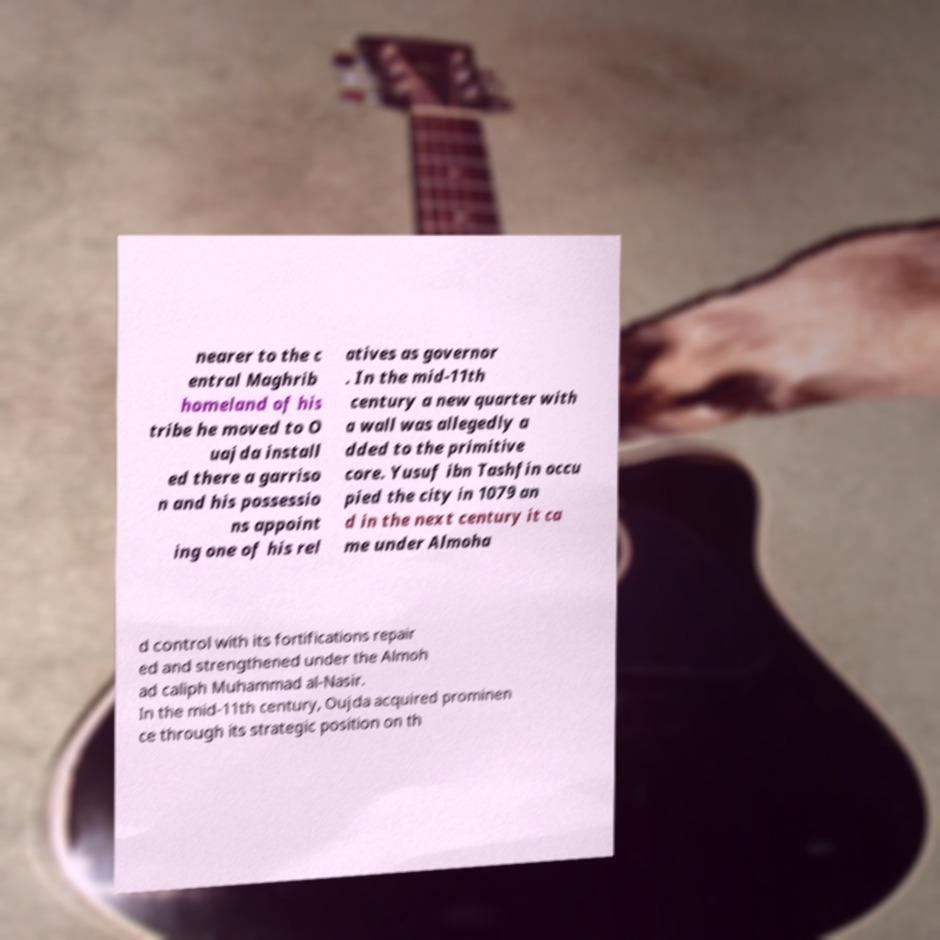There's text embedded in this image that I need extracted. Can you transcribe it verbatim? nearer to the c entral Maghrib homeland of his tribe he moved to O uajda install ed there a garriso n and his possessio ns appoint ing one of his rel atives as governor . In the mid-11th century a new quarter with a wall was allegedly a dded to the primitive core. Yusuf ibn Tashfin occu pied the city in 1079 an d in the next century it ca me under Almoha d control with its fortifications repair ed and strengthened under the Almoh ad caliph Muhammad al-Nasir. In the mid-11th century, Oujda acquired prominen ce through its strategic position on th 